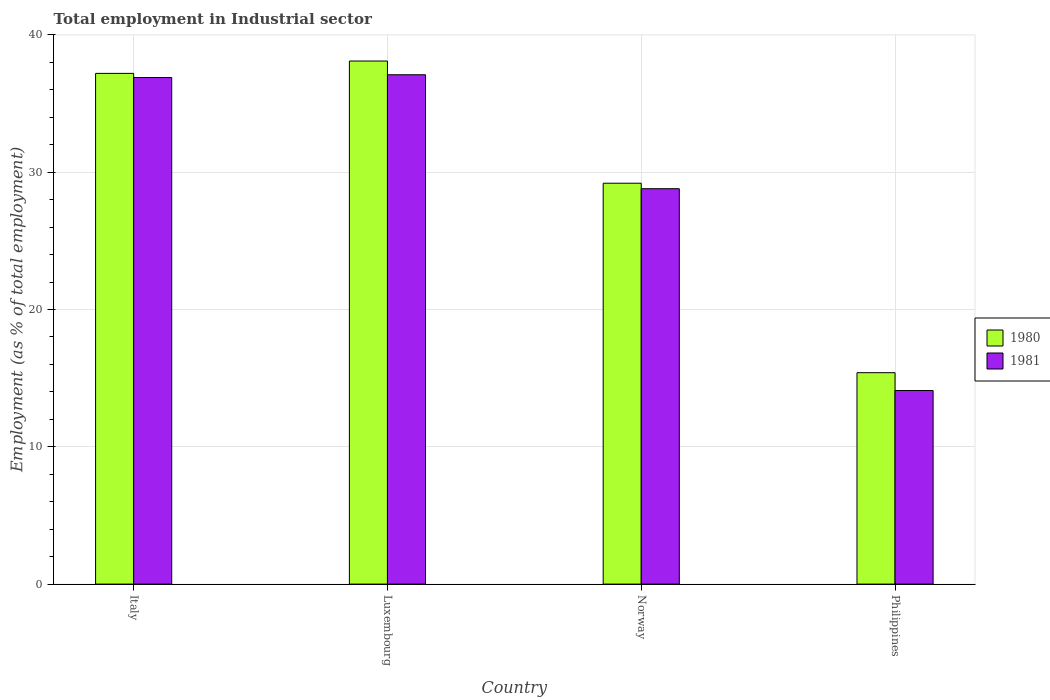How many different coloured bars are there?
Make the answer very short. 2. How many groups of bars are there?
Make the answer very short. 4. Are the number of bars per tick equal to the number of legend labels?
Provide a short and direct response. Yes. Are the number of bars on each tick of the X-axis equal?
Provide a succinct answer. Yes. What is the label of the 3rd group of bars from the left?
Your answer should be compact. Norway. In how many cases, is the number of bars for a given country not equal to the number of legend labels?
Provide a short and direct response. 0. What is the employment in industrial sector in 1980 in Philippines?
Your answer should be very brief. 15.4. Across all countries, what is the maximum employment in industrial sector in 1980?
Your answer should be compact. 38.1. Across all countries, what is the minimum employment in industrial sector in 1981?
Provide a short and direct response. 14.1. In which country was the employment in industrial sector in 1980 maximum?
Your answer should be very brief. Luxembourg. In which country was the employment in industrial sector in 1981 minimum?
Give a very brief answer. Philippines. What is the total employment in industrial sector in 1981 in the graph?
Provide a succinct answer. 116.9. What is the difference between the employment in industrial sector in 1981 in Luxembourg and that in Norway?
Your response must be concise. 8.3. What is the difference between the employment in industrial sector in 1980 in Norway and the employment in industrial sector in 1981 in Italy?
Give a very brief answer. -7.7. What is the average employment in industrial sector in 1980 per country?
Your answer should be compact. 29.97. What is the difference between the employment in industrial sector of/in 1981 and employment in industrial sector of/in 1980 in Philippines?
Offer a very short reply. -1.3. In how many countries, is the employment in industrial sector in 1981 greater than 26 %?
Give a very brief answer. 3. What is the ratio of the employment in industrial sector in 1980 in Luxembourg to that in Philippines?
Give a very brief answer. 2.47. Is the employment in industrial sector in 1980 in Norway less than that in Philippines?
Your response must be concise. No. Is the difference between the employment in industrial sector in 1981 in Norway and Philippines greater than the difference between the employment in industrial sector in 1980 in Norway and Philippines?
Provide a succinct answer. Yes. What is the difference between the highest and the second highest employment in industrial sector in 1980?
Make the answer very short. -8. What is the difference between the highest and the lowest employment in industrial sector in 1980?
Your answer should be compact. 22.7. Is the sum of the employment in industrial sector in 1980 in Italy and Norway greater than the maximum employment in industrial sector in 1981 across all countries?
Offer a terse response. Yes. How many bars are there?
Your answer should be compact. 8. What is the difference between two consecutive major ticks on the Y-axis?
Give a very brief answer. 10. Are the values on the major ticks of Y-axis written in scientific E-notation?
Offer a terse response. No. Does the graph contain any zero values?
Offer a terse response. No. What is the title of the graph?
Offer a very short reply. Total employment in Industrial sector. What is the label or title of the X-axis?
Your answer should be very brief. Country. What is the label or title of the Y-axis?
Your answer should be very brief. Employment (as % of total employment). What is the Employment (as % of total employment) of 1980 in Italy?
Ensure brevity in your answer.  37.2. What is the Employment (as % of total employment) in 1981 in Italy?
Your answer should be compact. 36.9. What is the Employment (as % of total employment) in 1980 in Luxembourg?
Offer a very short reply. 38.1. What is the Employment (as % of total employment) of 1981 in Luxembourg?
Ensure brevity in your answer.  37.1. What is the Employment (as % of total employment) in 1980 in Norway?
Offer a very short reply. 29.2. What is the Employment (as % of total employment) of 1981 in Norway?
Your answer should be very brief. 28.8. What is the Employment (as % of total employment) in 1980 in Philippines?
Provide a short and direct response. 15.4. What is the Employment (as % of total employment) in 1981 in Philippines?
Keep it short and to the point. 14.1. Across all countries, what is the maximum Employment (as % of total employment) of 1980?
Your answer should be compact. 38.1. Across all countries, what is the maximum Employment (as % of total employment) of 1981?
Ensure brevity in your answer.  37.1. Across all countries, what is the minimum Employment (as % of total employment) in 1980?
Make the answer very short. 15.4. Across all countries, what is the minimum Employment (as % of total employment) of 1981?
Your answer should be compact. 14.1. What is the total Employment (as % of total employment) in 1980 in the graph?
Offer a very short reply. 119.9. What is the total Employment (as % of total employment) in 1981 in the graph?
Offer a very short reply. 116.9. What is the difference between the Employment (as % of total employment) of 1980 in Italy and that in Luxembourg?
Provide a short and direct response. -0.9. What is the difference between the Employment (as % of total employment) in 1980 in Italy and that in Norway?
Offer a terse response. 8. What is the difference between the Employment (as % of total employment) in 1981 in Italy and that in Norway?
Give a very brief answer. 8.1. What is the difference between the Employment (as % of total employment) of 1980 in Italy and that in Philippines?
Ensure brevity in your answer.  21.8. What is the difference between the Employment (as % of total employment) of 1981 in Italy and that in Philippines?
Your response must be concise. 22.8. What is the difference between the Employment (as % of total employment) of 1980 in Luxembourg and that in Norway?
Provide a short and direct response. 8.9. What is the difference between the Employment (as % of total employment) in 1981 in Luxembourg and that in Norway?
Your answer should be very brief. 8.3. What is the difference between the Employment (as % of total employment) in 1980 in Luxembourg and that in Philippines?
Your answer should be very brief. 22.7. What is the difference between the Employment (as % of total employment) of 1981 in Luxembourg and that in Philippines?
Ensure brevity in your answer.  23. What is the difference between the Employment (as % of total employment) of 1980 in Norway and that in Philippines?
Your answer should be very brief. 13.8. What is the difference between the Employment (as % of total employment) in 1981 in Norway and that in Philippines?
Provide a succinct answer. 14.7. What is the difference between the Employment (as % of total employment) in 1980 in Italy and the Employment (as % of total employment) in 1981 in Norway?
Make the answer very short. 8.4. What is the difference between the Employment (as % of total employment) of 1980 in Italy and the Employment (as % of total employment) of 1981 in Philippines?
Your response must be concise. 23.1. What is the difference between the Employment (as % of total employment) in 1980 in Luxembourg and the Employment (as % of total employment) in 1981 in Philippines?
Offer a terse response. 24. What is the average Employment (as % of total employment) of 1980 per country?
Your response must be concise. 29.98. What is the average Employment (as % of total employment) in 1981 per country?
Ensure brevity in your answer.  29.23. What is the difference between the Employment (as % of total employment) of 1980 and Employment (as % of total employment) of 1981 in Italy?
Offer a terse response. 0.3. What is the difference between the Employment (as % of total employment) in 1980 and Employment (as % of total employment) in 1981 in Luxembourg?
Your answer should be very brief. 1. What is the difference between the Employment (as % of total employment) in 1980 and Employment (as % of total employment) in 1981 in Philippines?
Your response must be concise. 1.3. What is the ratio of the Employment (as % of total employment) in 1980 in Italy to that in Luxembourg?
Give a very brief answer. 0.98. What is the ratio of the Employment (as % of total employment) in 1980 in Italy to that in Norway?
Give a very brief answer. 1.27. What is the ratio of the Employment (as % of total employment) of 1981 in Italy to that in Norway?
Keep it short and to the point. 1.28. What is the ratio of the Employment (as % of total employment) in 1980 in Italy to that in Philippines?
Provide a short and direct response. 2.42. What is the ratio of the Employment (as % of total employment) in 1981 in Italy to that in Philippines?
Keep it short and to the point. 2.62. What is the ratio of the Employment (as % of total employment) of 1980 in Luxembourg to that in Norway?
Offer a terse response. 1.3. What is the ratio of the Employment (as % of total employment) of 1981 in Luxembourg to that in Norway?
Provide a succinct answer. 1.29. What is the ratio of the Employment (as % of total employment) in 1980 in Luxembourg to that in Philippines?
Keep it short and to the point. 2.47. What is the ratio of the Employment (as % of total employment) in 1981 in Luxembourg to that in Philippines?
Your response must be concise. 2.63. What is the ratio of the Employment (as % of total employment) in 1980 in Norway to that in Philippines?
Provide a short and direct response. 1.9. What is the ratio of the Employment (as % of total employment) in 1981 in Norway to that in Philippines?
Provide a short and direct response. 2.04. What is the difference between the highest and the lowest Employment (as % of total employment) of 1980?
Keep it short and to the point. 22.7. 